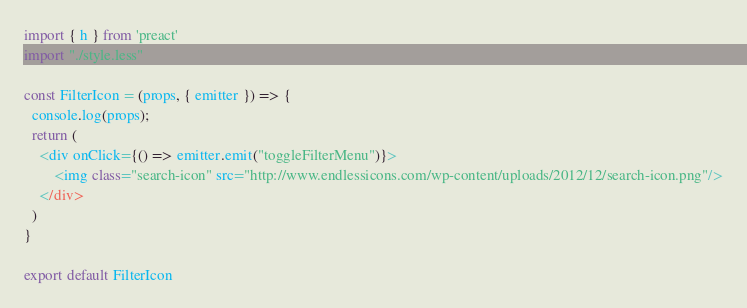<code> <loc_0><loc_0><loc_500><loc_500><_JavaScript_>import { h } from 'preact'
import "./style.less"

const FilterIcon = (props, { emitter }) => {
  console.log(props);
  return (
    <div onClick={() => emitter.emit("toggleFilterMenu")}>
        <img class="search-icon" src="http://www.endlessicons.com/wp-content/uploads/2012/12/search-icon.png"/>
    </div>
  )
}

export default FilterIcon
</code> 